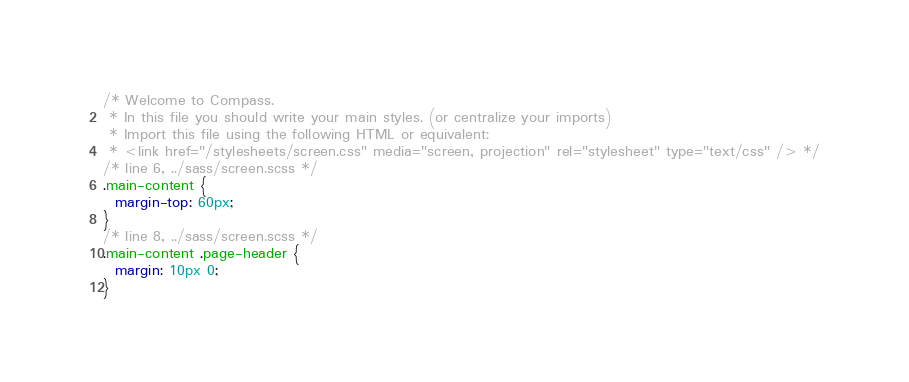<code> <loc_0><loc_0><loc_500><loc_500><_CSS_>/* Welcome to Compass.
 * In this file you should write your main styles. (or centralize your imports)
 * Import this file using the following HTML or equivalent:
 * <link href="/stylesheets/screen.css" media="screen, projection" rel="stylesheet" type="text/css" /> */
/* line 6, ../sass/screen.scss */
.main-content {
  margin-top: 60px;
}
/* line 8, ../sass/screen.scss */
.main-content .page-header {
  margin: 10px 0;
}
</code> 